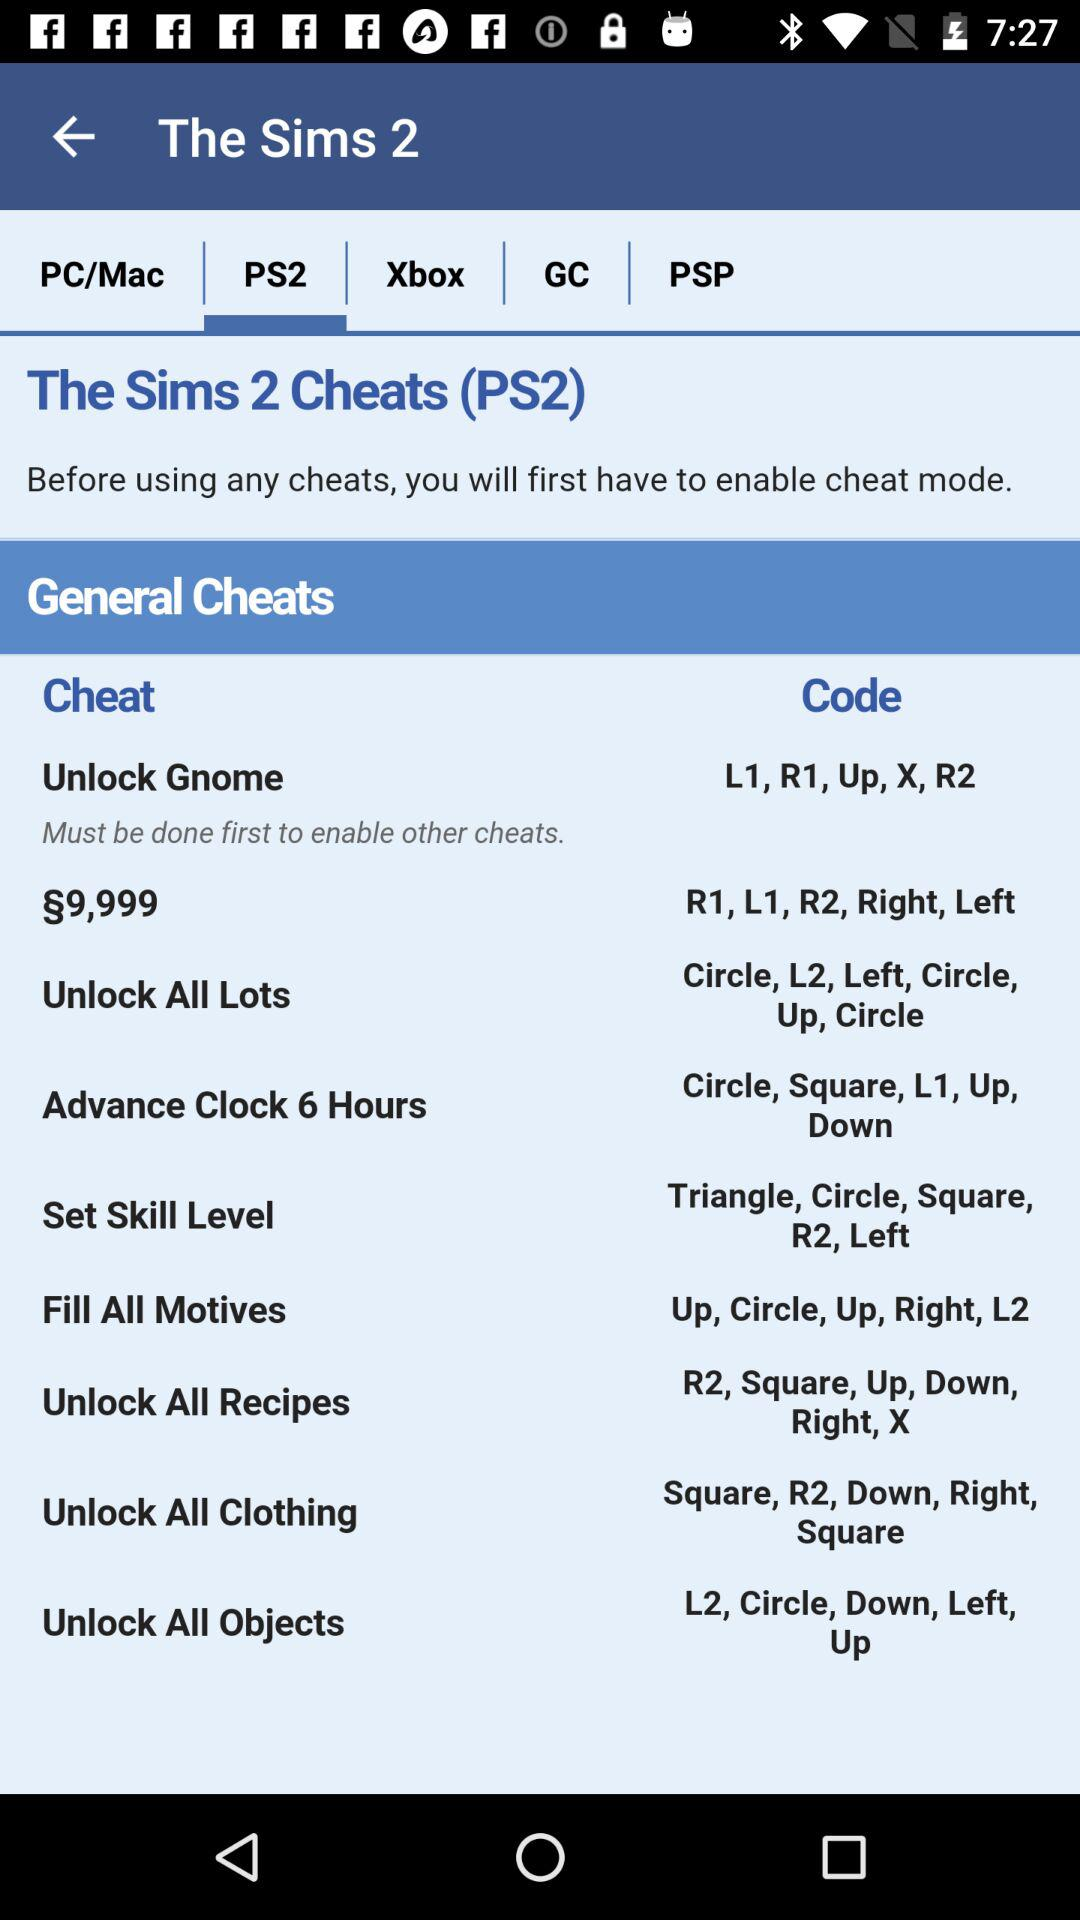Which is the selected tab? The selected tab is PS2. 